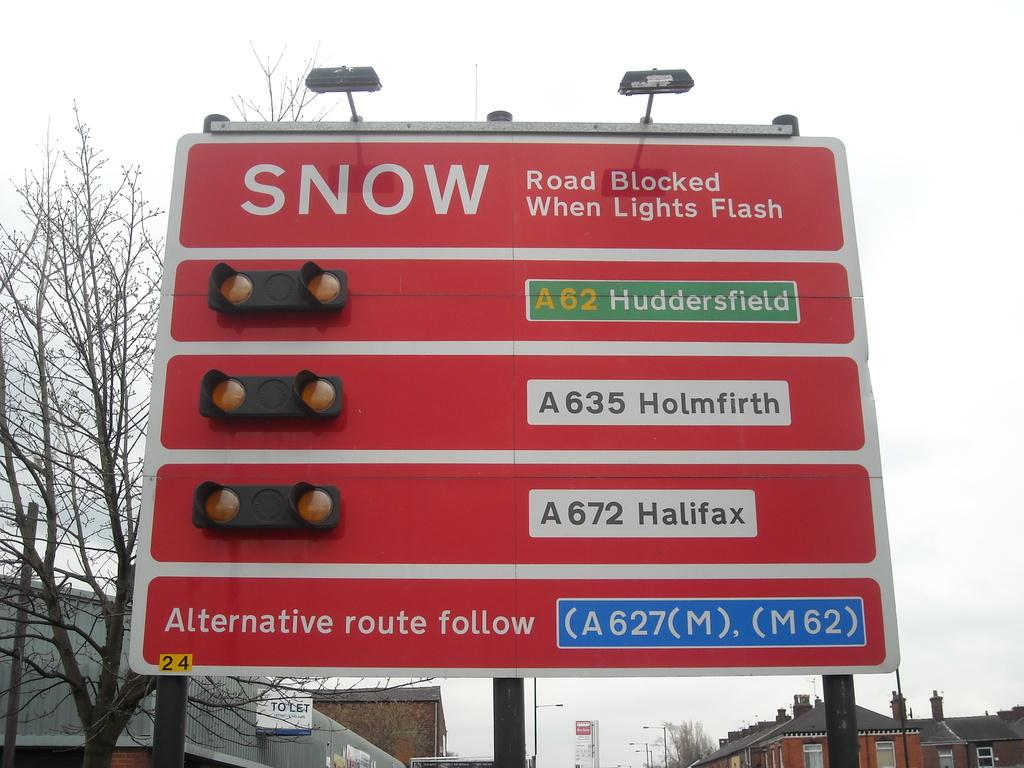<image>
Present a compact description of the photo's key features. a red road sign for SNOW reads Road Blocked When Lights Flash 